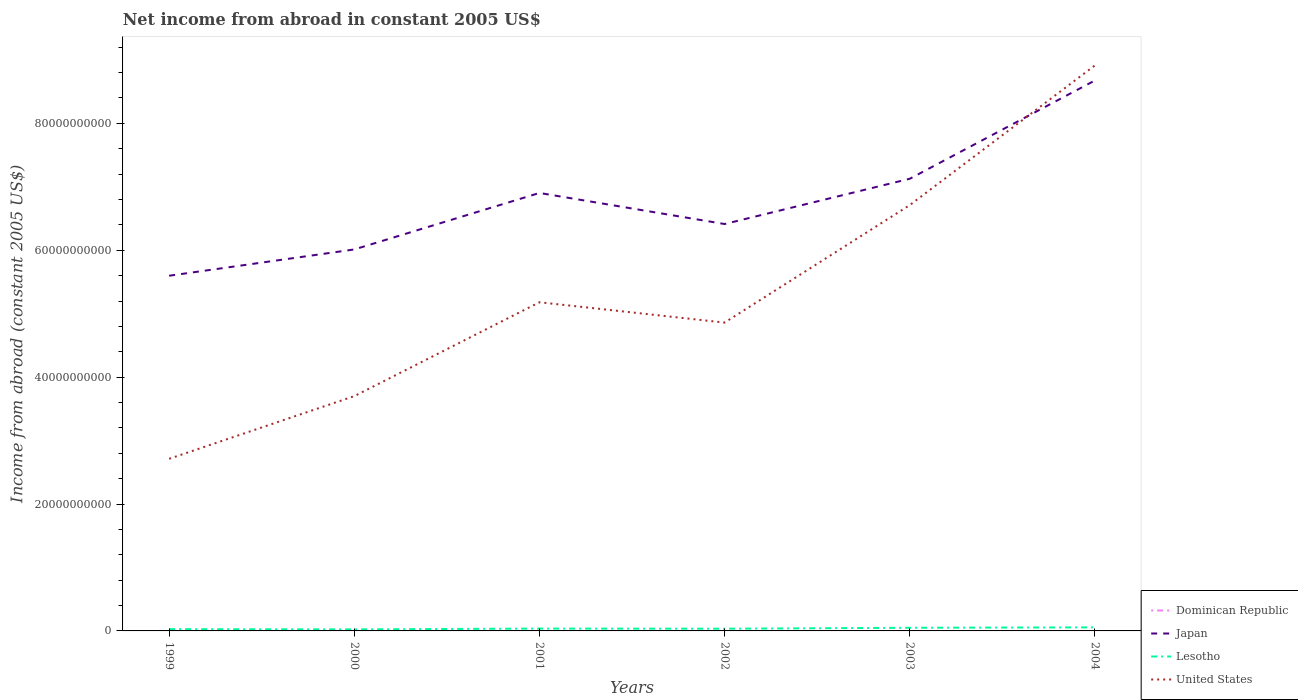Does the line corresponding to Lesotho intersect with the line corresponding to Japan?
Your answer should be very brief. No. Across all years, what is the maximum net income from abroad in Japan?
Give a very brief answer. 5.60e+1. What is the total net income from abroad in Japan in the graph?
Provide a short and direct response. -2.26e+1. What is the difference between the highest and the second highest net income from abroad in Japan?
Ensure brevity in your answer.  3.08e+1. Is the net income from abroad in Japan strictly greater than the net income from abroad in United States over the years?
Offer a terse response. No. How many years are there in the graph?
Your answer should be compact. 6. Are the values on the major ticks of Y-axis written in scientific E-notation?
Provide a succinct answer. No. Does the graph contain any zero values?
Your response must be concise. Yes. How many legend labels are there?
Offer a terse response. 4. What is the title of the graph?
Make the answer very short. Net income from abroad in constant 2005 US$. Does "Middle income" appear as one of the legend labels in the graph?
Make the answer very short. No. What is the label or title of the Y-axis?
Your response must be concise. Income from abroad (constant 2005 US$). What is the Income from abroad (constant 2005 US$) of Japan in 1999?
Give a very brief answer. 5.60e+1. What is the Income from abroad (constant 2005 US$) in Lesotho in 1999?
Offer a very short reply. 2.82e+08. What is the Income from abroad (constant 2005 US$) in United States in 1999?
Keep it short and to the point. 2.71e+1. What is the Income from abroad (constant 2005 US$) of Dominican Republic in 2000?
Your answer should be compact. 0. What is the Income from abroad (constant 2005 US$) of Japan in 2000?
Your answer should be very brief. 6.01e+1. What is the Income from abroad (constant 2005 US$) of Lesotho in 2000?
Your answer should be very brief. 2.43e+08. What is the Income from abroad (constant 2005 US$) of United States in 2000?
Make the answer very short. 3.70e+1. What is the Income from abroad (constant 2005 US$) of Japan in 2001?
Your answer should be very brief. 6.90e+1. What is the Income from abroad (constant 2005 US$) of Lesotho in 2001?
Ensure brevity in your answer.  3.69e+08. What is the Income from abroad (constant 2005 US$) in United States in 2001?
Ensure brevity in your answer.  5.18e+1. What is the Income from abroad (constant 2005 US$) in Japan in 2002?
Ensure brevity in your answer.  6.41e+1. What is the Income from abroad (constant 2005 US$) in Lesotho in 2002?
Offer a very short reply. 3.48e+08. What is the Income from abroad (constant 2005 US$) in United States in 2002?
Offer a terse response. 4.86e+1. What is the Income from abroad (constant 2005 US$) of Japan in 2003?
Offer a very short reply. 7.13e+1. What is the Income from abroad (constant 2005 US$) of Lesotho in 2003?
Offer a terse response. 4.97e+08. What is the Income from abroad (constant 2005 US$) of United States in 2003?
Provide a short and direct response. 6.71e+1. What is the Income from abroad (constant 2005 US$) in Japan in 2004?
Your response must be concise. 8.68e+1. What is the Income from abroad (constant 2005 US$) of Lesotho in 2004?
Your response must be concise. 5.62e+08. What is the Income from abroad (constant 2005 US$) of United States in 2004?
Give a very brief answer. 8.91e+1. Across all years, what is the maximum Income from abroad (constant 2005 US$) of Japan?
Offer a very short reply. 8.68e+1. Across all years, what is the maximum Income from abroad (constant 2005 US$) of Lesotho?
Provide a short and direct response. 5.62e+08. Across all years, what is the maximum Income from abroad (constant 2005 US$) of United States?
Provide a succinct answer. 8.91e+1. Across all years, what is the minimum Income from abroad (constant 2005 US$) of Japan?
Keep it short and to the point. 5.60e+1. Across all years, what is the minimum Income from abroad (constant 2005 US$) in Lesotho?
Keep it short and to the point. 2.43e+08. Across all years, what is the minimum Income from abroad (constant 2005 US$) in United States?
Provide a succinct answer. 2.71e+1. What is the total Income from abroad (constant 2005 US$) of Dominican Republic in the graph?
Keep it short and to the point. 0. What is the total Income from abroad (constant 2005 US$) in Japan in the graph?
Offer a terse response. 4.07e+11. What is the total Income from abroad (constant 2005 US$) of Lesotho in the graph?
Provide a succinct answer. 2.30e+09. What is the total Income from abroad (constant 2005 US$) in United States in the graph?
Keep it short and to the point. 3.21e+11. What is the difference between the Income from abroad (constant 2005 US$) in Japan in 1999 and that in 2000?
Your answer should be very brief. -4.14e+09. What is the difference between the Income from abroad (constant 2005 US$) of Lesotho in 1999 and that in 2000?
Ensure brevity in your answer.  3.91e+07. What is the difference between the Income from abroad (constant 2005 US$) of United States in 1999 and that in 2000?
Your answer should be compact. -9.88e+09. What is the difference between the Income from abroad (constant 2005 US$) in Japan in 1999 and that in 2001?
Your answer should be compact. -1.30e+1. What is the difference between the Income from abroad (constant 2005 US$) in Lesotho in 1999 and that in 2001?
Make the answer very short. -8.63e+07. What is the difference between the Income from abroad (constant 2005 US$) of United States in 1999 and that in 2001?
Keep it short and to the point. -2.47e+1. What is the difference between the Income from abroad (constant 2005 US$) of Japan in 1999 and that in 2002?
Make the answer very short. -8.15e+09. What is the difference between the Income from abroad (constant 2005 US$) in Lesotho in 1999 and that in 2002?
Your answer should be compact. -6.52e+07. What is the difference between the Income from abroad (constant 2005 US$) in United States in 1999 and that in 2002?
Your answer should be compact. -2.15e+1. What is the difference between the Income from abroad (constant 2005 US$) in Japan in 1999 and that in 2003?
Make the answer very short. -1.53e+1. What is the difference between the Income from abroad (constant 2005 US$) in Lesotho in 1999 and that in 2003?
Your answer should be very brief. -2.15e+08. What is the difference between the Income from abroad (constant 2005 US$) of United States in 1999 and that in 2003?
Keep it short and to the point. -4.00e+1. What is the difference between the Income from abroad (constant 2005 US$) in Japan in 1999 and that in 2004?
Offer a very short reply. -3.08e+1. What is the difference between the Income from abroad (constant 2005 US$) of Lesotho in 1999 and that in 2004?
Ensure brevity in your answer.  -2.79e+08. What is the difference between the Income from abroad (constant 2005 US$) in United States in 1999 and that in 2004?
Offer a very short reply. -6.20e+1. What is the difference between the Income from abroad (constant 2005 US$) in Japan in 2000 and that in 2001?
Provide a short and direct response. -8.90e+09. What is the difference between the Income from abroad (constant 2005 US$) in Lesotho in 2000 and that in 2001?
Your answer should be very brief. -1.25e+08. What is the difference between the Income from abroad (constant 2005 US$) of United States in 2000 and that in 2001?
Your answer should be very brief. -1.48e+1. What is the difference between the Income from abroad (constant 2005 US$) of Japan in 2000 and that in 2002?
Offer a terse response. -4.01e+09. What is the difference between the Income from abroad (constant 2005 US$) in Lesotho in 2000 and that in 2002?
Keep it short and to the point. -1.04e+08. What is the difference between the Income from abroad (constant 2005 US$) of United States in 2000 and that in 2002?
Ensure brevity in your answer.  -1.16e+1. What is the difference between the Income from abroad (constant 2005 US$) in Japan in 2000 and that in 2003?
Offer a terse response. -1.11e+1. What is the difference between the Income from abroad (constant 2005 US$) in Lesotho in 2000 and that in 2003?
Provide a succinct answer. -2.54e+08. What is the difference between the Income from abroad (constant 2005 US$) of United States in 2000 and that in 2003?
Keep it short and to the point. -3.01e+1. What is the difference between the Income from abroad (constant 2005 US$) of Japan in 2000 and that in 2004?
Provide a short and direct response. -2.66e+1. What is the difference between the Income from abroad (constant 2005 US$) in Lesotho in 2000 and that in 2004?
Provide a short and direct response. -3.18e+08. What is the difference between the Income from abroad (constant 2005 US$) of United States in 2000 and that in 2004?
Make the answer very short. -5.21e+1. What is the difference between the Income from abroad (constant 2005 US$) of Japan in 2001 and that in 2002?
Your answer should be very brief. 4.90e+09. What is the difference between the Income from abroad (constant 2005 US$) of Lesotho in 2001 and that in 2002?
Provide a succinct answer. 2.12e+07. What is the difference between the Income from abroad (constant 2005 US$) in United States in 2001 and that in 2002?
Your answer should be very brief. 3.20e+09. What is the difference between the Income from abroad (constant 2005 US$) of Japan in 2001 and that in 2003?
Ensure brevity in your answer.  -2.24e+09. What is the difference between the Income from abroad (constant 2005 US$) in Lesotho in 2001 and that in 2003?
Give a very brief answer. -1.28e+08. What is the difference between the Income from abroad (constant 2005 US$) in United States in 2001 and that in 2003?
Ensure brevity in your answer.  -1.53e+1. What is the difference between the Income from abroad (constant 2005 US$) in Japan in 2001 and that in 2004?
Give a very brief answer. -1.77e+1. What is the difference between the Income from abroad (constant 2005 US$) of Lesotho in 2001 and that in 2004?
Offer a very short reply. -1.93e+08. What is the difference between the Income from abroad (constant 2005 US$) in United States in 2001 and that in 2004?
Give a very brief answer. -3.73e+1. What is the difference between the Income from abroad (constant 2005 US$) in Japan in 2002 and that in 2003?
Your response must be concise. -7.13e+09. What is the difference between the Income from abroad (constant 2005 US$) of Lesotho in 2002 and that in 2003?
Make the answer very short. -1.50e+08. What is the difference between the Income from abroad (constant 2005 US$) in United States in 2002 and that in 2003?
Keep it short and to the point. -1.85e+1. What is the difference between the Income from abroad (constant 2005 US$) of Japan in 2002 and that in 2004?
Offer a very short reply. -2.26e+1. What is the difference between the Income from abroad (constant 2005 US$) of Lesotho in 2002 and that in 2004?
Offer a terse response. -2.14e+08. What is the difference between the Income from abroad (constant 2005 US$) in United States in 2002 and that in 2004?
Your answer should be very brief. -4.05e+1. What is the difference between the Income from abroad (constant 2005 US$) in Japan in 2003 and that in 2004?
Make the answer very short. -1.55e+1. What is the difference between the Income from abroad (constant 2005 US$) of Lesotho in 2003 and that in 2004?
Offer a very short reply. -6.46e+07. What is the difference between the Income from abroad (constant 2005 US$) in United States in 2003 and that in 2004?
Keep it short and to the point. -2.20e+1. What is the difference between the Income from abroad (constant 2005 US$) of Japan in 1999 and the Income from abroad (constant 2005 US$) of Lesotho in 2000?
Your response must be concise. 5.57e+1. What is the difference between the Income from abroad (constant 2005 US$) in Japan in 1999 and the Income from abroad (constant 2005 US$) in United States in 2000?
Provide a succinct answer. 1.90e+1. What is the difference between the Income from abroad (constant 2005 US$) of Lesotho in 1999 and the Income from abroad (constant 2005 US$) of United States in 2000?
Make the answer very short. -3.67e+1. What is the difference between the Income from abroad (constant 2005 US$) in Japan in 1999 and the Income from abroad (constant 2005 US$) in Lesotho in 2001?
Offer a terse response. 5.56e+1. What is the difference between the Income from abroad (constant 2005 US$) of Japan in 1999 and the Income from abroad (constant 2005 US$) of United States in 2001?
Give a very brief answer. 4.18e+09. What is the difference between the Income from abroad (constant 2005 US$) in Lesotho in 1999 and the Income from abroad (constant 2005 US$) in United States in 2001?
Keep it short and to the point. -5.15e+1. What is the difference between the Income from abroad (constant 2005 US$) in Japan in 1999 and the Income from abroad (constant 2005 US$) in Lesotho in 2002?
Offer a terse response. 5.56e+1. What is the difference between the Income from abroad (constant 2005 US$) in Japan in 1999 and the Income from abroad (constant 2005 US$) in United States in 2002?
Give a very brief answer. 7.38e+09. What is the difference between the Income from abroad (constant 2005 US$) in Lesotho in 1999 and the Income from abroad (constant 2005 US$) in United States in 2002?
Give a very brief answer. -4.83e+1. What is the difference between the Income from abroad (constant 2005 US$) of Japan in 1999 and the Income from abroad (constant 2005 US$) of Lesotho in 2003?
Ensure brevity in your answer.  5.55e+1. What is the difference between the Income from abroad (constant 2005 US$) of Japan in 1999 and the Income from abroad (constant 2005 US$) of United States in 2003?
Your answer should be compact. -1.11e+1. What is the difference between the Income from abroad (constant 2005 US$) of Lesotho in 1999 and the Income from abroad (constant 2005 US$) of United States in 2003?
Make the answer very short. -6.68e+1. What is the difference between the Income from abroad (constant 2005 US$) of Japan in 1999 and the Income from abroad (constant 2005 US$) of Lesotho in 2004?
Offer a terse response. 5.54e+1. What is the difference between the Income from abroad (constant 2005 US$) of Japan in 1999 and the Income from abroad (constant 2005 US$) of United States in 2004?
Your answer should be compact. -3.31e+1. What is the difference between the Income from abroad (constant 2005 US$) of Lesotho in 1999 and the Income from abroad (constant 2005 US$) of United States in 2004?
Your answer should be very brief. -8.88e+1. What is the difference between the Income from abroad (constant 2005 US$) of Japan in 2000 and the Income from abroad (constant 2005 US$) of Lesotho in 2001?
Ensure brevity in your answer.  5.98e+1. What is the difference between the Income from abroad (constant 2005 US$) in Japan in 2000 and the Income from abroad (constant 2005 US$) in United States in 2001?
Give a very brief answer. 8.32e+09. What is the difference between the Income from abroad (constant 2005 US$) of Lesotho in 2000 and the Income from abroad (constant 2005 US$) of United States in 2001?
Your answer should be very brief. -5.16e+1. What is the difference between the Income from abroad (constant 2005 US$) of Japan in 2000 and the Income from abroad (constant 2005 US$) of Lesotho in 2002?
Offer a terse response. 5.98e+1. What is the difference between the Income from abroad (constant 2005 US$) of Japan in 2000 and the Income from abroad (constant 2005 US$) of United States in 2002?
Make the answer very short. 1.15e+1. What is the difference between the Income from abroad (constant 2005 US$) of Lesotho in 2000 and the Income from abroad (constant 2005 US$) of United States in 2002?
Offer a very short reply. -4.84e+1. What is the difference between the Income from abroad (constant 2005 US$) in Japan in 2000 and the Income from abroad (constant 2005 US$) in Lesotho in 2003?
Offer a terse response. 5.96e+1. What is the difference between the Income from abroad (constant 2005 US$) in Japan in 2000 and the Income from abroad (constant 2005 US$) in United States in 2003?
Your answer should be compact. -6.99e+09. What is the difference between the Income from abroad (constant 2005 US$) of Lesotho in 2000 and the Income from abroad (constant 2005 US$) of United States in 2003?
Provide a short and direct response. -6.69e+1. What is the difference between the Income from abroad (constant 2005 US$) of Japan in 2000 and the Income from abroad (constant 2005 US$) of Lesotho in 2004?
Offer a terse response. 5.96e+1. What is the difference between the Income from abroad (constant 2005 US$) in Japan in 2000 and the Income from abroad (constant 2005 US$) in United States in 2004?
Provide a short and direct response. -2.90e+1. What is the difference between the Income from abroad (constant 2005 US$) in Lesotho in 2000 and the Income from abroad (constant 2005 US$) in United States in 2004?
Your response must be concise. -8.89e+1. What is the difference between the Income from abroad (constant 2005 US$) in Japan in 2001 and the Income from abroad (constant 2005 US$) in Lesotho in 2002?
Provide a succinct answer. 6.87e+1. What is the difference between the Income from abroad (constant 2005 US$) in Japan in 2001 and the Income from abroad (constant 2005 US$) in United States in 2002?
Give a very brief answer. 2.04e+1. What is the difference between the Income from abroad (constant 2005 US$) of Lesotho in 2001 and the Income from abroad (constant 2005 US$) of United States in 2002?
Keep it short and to the point. -4.82e+1. What is the difference between the Income from abroad (constant 2005 US$) in Japan in 2001 and the Income from abroad (constant 2005 US$) in Lesotho in 2003?
Give a very brief answer. 6.85e+1. What is the difference between the Income from abroad (constant 2005 US$) in Japan in 2001 and the Income from abroad (constant 2005 US$) in United States in 2003?
Keep it short and to the point. 1.92e+09. What is the difference between the Income from abroad (constant 2005 US$) of Lesotho in 2001 and the Income from abroad (constant 2005 US$) of United States in 2003?
Your answer should be compact. -6.67e+1. What is the difference between the Income from abroad (constant 2005 US$) of Japan in 2001 and the Income from abroad (constant 2005 US$) of Lesotho in 2004?
Provide a succinct answer. 6.85e+1. What is the difference between the Income from abroad (constant 2005 US$) in Japan in 2001 and the Income from abroad (constant 2005 US$) in United States in 2004?
Provide a succinct answer. -2.01e+1. What is the difference between the Income from abroad (constant 2005 US$) in Lesotho in 2001 and the Income from abroad (constant 2005 US$) in United States in 2004?
Ensure brevity in your answer.  -8.88e+1. What is the difference between the Income from abroad (constant 2005 US$) of Japan in 2002 and the Income from abroad (constant 2005 US$) of Lesotho in 2003?
Your answer should be compact. 6.36e+1. What is the difference between the Income from abroad (constant 2005 US$) in Japan in 2002 and the Income from abroad (constant 2005 US$) in United States in 2003?
Ensure brevity in your answer.  -2.98e+09. What is the difference between the Income from abroad (constant 2005 US$) in Lesotho in 2002 and the Income from abroad (constant 2005 US$) in United States in 2003?
Ensure brevity in your answer.  -6.68e+1. What is the difference between the Income from abroad (constant 2005 US$) of Japan in 2002 and the Income from abroad (constant 2005 US$) of Lesotho in 2004?
Ensure brevity in your answer.  6.36e+1. What is the difference between the Income from abroad (constant 2005 US$) of Japan in 2002 and the Income from abroad (constant 2005 US$) of United States in 2004?
Make the answer very short. -2.50e+1. What is the difference between the Income from abroad (constant 2005 US$) in Lesotho in 2002 and the Income from abroad (constant 2005 US$) in United States in 2004?
Your response must be concise. -8.88e+1. What is the difference between the Income from abroad (constant 2005 US$) in Japan in 2003 and the Income from abroad (constant 2005 US$) in Lesotho in 2004?
Give a very brief answer. 7.07e+1. What is the difference between the Income from abroad (constant 2005 US$) of Japan in 2003 and the Income from abroad (constant 2005 US$) of United States in 2004?
Make the answer very short. -1.79e+1. What is the difference between the Income from abroad (constant 2005 US$) in Lesotho in 2003 and the Income from abroad (constant 2005 US$) in United States in 2004?
Offer a very short reply. -8.86e+1. What is the average Income from abroad (constant 2005 US$) in Dominican Republic per year?
Offer a very short reply. 0. What is the average Income from abroad (constant 2005 US$) in Japan per year?
Offer a very short reply. 6.79e+1. What is the average Income from abroad (constant 2005 US$) of Lesotho per year?
Provide a succinct answer. 3.83e+08. What is the average Income from abroad (constant 2005 US$) in United States per year?
Give a very brief answer. 5.35e+1. In the year 1999, what is the difference between the Income from abroad (constant 2005 US$) in Japan and Income from abroad (constant 2005 US$) in Lesotho?
Provide a short and direct response. 5.57e+1. In the year 1999, what is the difference between the Income from abroad (constant 2005 US$) of Japan and Income from abroad (constant 2005 US$) of United States?
Provide a short and direct response. 2.89e+1. In the year 1999, what is the difference between the Income from abroad (constant 2005 US$) in Lesotho and Income from abroad (constant 2005 US$) in United States?
Offer a very short reply. -2.68e+1. In the year 2000, what is the difference between the Income from abroad (constant 2005 US$) of Japan and Income from abroad (constant 2005 US$) of Lesotho?
Provide a short and direct response. 5.99e+1. In the year 2000, what is the difference between the Income from abroad (constant 2005 US$) in Japan and Income from abroad (constant 2005 US$) in United States?
Provide a short and direct response. 2.31e+1. In the year 2000, what is the difference between the Income from abroad (constant 2005 US$) of Lesotho and Income from abroad (constant 2005 US$) of United States?
Provide a short and direct response. -3.68e+1. In the year 2001, what is the difference between the Income from abroad (constant 2005 US$) of Japan and Income from abroad (constant 2005 US$) of Lesotho?
Provide a short and direct response. 6.87e+1. In the year 2001, what is the difference between the Income from abroad (constant 2005 US$) in Japan and Income from abroad (constant 2005 US$) in United States?
Ensure brevity in your answer.  1.72e+1. In the year 2001, what is the difference between the Income from abroad (constant 2005 US$) in Lesotho and Income from abroad (constant 2005 US$) in United States?
Your answer should be compact. -5.14e+1. In the year 2002, what is the difference between the Income from abroad (constant 2005 US$) of Japan and Income from abroad (constant 2005 US$) of Lesotho?
Ensure brevity in your answer.  6.38e+1. In the year 2002, what is the difference between the Income from abroad (constant 2005 US$) of Japan and Income from abroad (constant 2005 US$) of United States?
Offer a very short reply. 1.55e+1. In the year 2002, what is the difference between the Income from abroad (constant 2005 US$) of Lesotho and Income from abroad (constant 2005 US$) of United States?
Make the answer very short. -4.83e+1. In the year 2003, what is the difference between the Income from abroad (constant 2005 US$) in Japan and Income from abroad (constant 2005 US$) in Lesotho?
Keep it short and to the point. 7.08e+1. In the year 2003, what is the difference between the Income from abroad (constant 2005 US$) in Japan and Income from abroad (constant 2005 US$) in United States?
Make the answer very short. 4.15e+09. In the year 2003, what is the difference between the Income from abroad (constant 2005 US$) in Lesotho and Income from abroad (constant 2005 US$) in United States?
Give a very brief answer. -6.66e+1. In the year 2004, what is the difference between the Income from abroad (constant 2005 US$) of Japan and Income from abroad (constant 2005 US$) of Lesotho?
Your answer should be compact. 8.62e+1. In the year 2004, what is the difference between the Income from abroad (constant 2005 US$) in Japan and Income from abroad (constant 2005 US$) in United States?
Ensure brevity in your answer.  -2.38e+09. In the year 2004, what is the difference between the Income from abroad (constant 2005 US$) of Lesotho and Income from abroad (constant 2005 US$) of United States?
Offer a very short reply. -8.86e+1. What is the ratio of the Income from abroad (constant 2005 US$) in Japan in 1999 to that in 2000?
Keep it short and to the point. 0.93. What is the ratio of the Income from abroad (constant 2005 US$) in Lesotho in 1999 to that in 2000?
Offer a very short reply. 1.16. What is the ratio of the Income from abroad (constant 2005 US$) of United States in 1999 to that in 2000?
Make the answer very short. 0.73. What is the ratio of the Income from abroad (constant 2005 US$) of Japan in 1999 to that in 2001?
Offer a terse response. 0.81. What is the ratio of the Income from abroad (constant 2005 US$) in Lesotho in 1999 to that in 2001?
Make the answer very short. 0.77. What is the ratio of the Income from abroad (constant 2005 US$) in United States in 1999 to that in 2001?
Offer a very short reply. 0.52. What is the ratio of the Income from abroad (constant 2005 US$) in Japan in 1999 to that in 2002?
Give a very brief answer. 0.87. What is the ratio of the Income from abroad (constant 2005 US$) in Lesotho in 1999 to that in 2002?
Provide a succinct answer. 0.81. What is the ratio of the Income from abroad (constant 2005 US$) in United States in 1999 to that in 2002?
Make the answer very short. 0.56. What is the ratio of the Income from abroad (constant 2005 US$) of Japan in 1999 to that in 2003?
Make the answer very short. 0.79. What is the ratio of the Income from abroad (constant 2005 US$) of Lesotho in 1999 to that in 2003?
Your response must be concise. 0.57. What is the ratio of the Income from abroad (constant 2005 US$) in United States in 1999 to that in 2003?
Your response must be concise. 0.4. What is the ratio of the Income from abroad (constant 2005 US$) in Japan in 1999 to that in 2004?
Offer a very short reply. 0.65. What is the ratio of the Income from abroad (constant 2005 US$) in Lesotho in 1999 to that in 2004?
Provide a succinct answer. 0.5. What is the ratio of the Income from abroad (constant 2005 US$) of United States in 1999 to that in 2004?
Give a very brief answer. 0.3. What is the ratio of the Income from abroad (constant 2005 US$) of Japan in 2000 to that in 2001?
Ensure brevity in your answer.  0.87. What is the ratio of the Income from abroad (constant 2005 US$) in Lesotho in 2000 to that in 2001?
Give a very brief answer. 0.66. What is the ratio of the Income from abroad (constant 2005 US$) of United States in 2000 to that in 2001?
Keep it short and to the point. 0.71. What is the ratio of the Income from abroad (constant 2005 US$) of Japan in 2000 to that in 2002?
Give a very brief answer. 0.94. What is the ratio of the Income from abroad (constant 2005 US$) of Lesotho in 2000 to that in 2002?
Ensure brevity in your answer.  0.7. What is the ratio of the Income from abroad (constant 2005 US$) in United States in 2000 to that in 2002?
Provide a succinct answer. 0.76. What is the ratio of the Income from abroad (constant 2005 US$) of Japan in 2000 to that in 2003?
Ensure brevity in your answer.  0.84. What is the ratio of the Income from abroad (constant 2005 US$) of Lesotho in 2000 to that in 2003?
Provide a succinct answer. 0.49. What is the ratio of the Income from abroad (constant 2005 US$) of United States in 2000 to that in 2003?
Offer a terse response. 0.55. What is the ratio of the Income from abroad (constant 2005 US$) in Japan in 2000 to that in 2004?
Your response must be concise. 0.69. What is the ratio of the Income from abroad (constant 2005 US$) of Lesotho in 2000 to that in 2004?
Provide a succinct answer. 0.43. What is the ratio of the Income from abroad (constant 2005 US$) of United States in 2000 to that in 2004?
Your answer should be very brief. 0.42. What is the ratio of the Income from abroad (constant 2005 US$) in Japan in 2001 to that in 2002?
Offer a very short reply. 1.08. What is the ratio of the Income from abroad (constant 2005 US$) in Lesotho in 2001 to that in 2002?
Offer a very short reply. 1.06. What is the ratio of the Income from abroad (constant 2005 US$) in United States in 2001 to that in 2002?
Make the answer very short. 1.07. What is the ratio of the Income from abroad (constant 2005 US$) in Japan in 2001 to that in 2003?
Your answer should be compact. 0.97. What is the ratio of the Income from abroad (constant 2005 US$) of Lesotho in 2001 to that in 2003?
Offer a very short reply. 0.74. What is the ratio of the Income from abroad (constant 2005 US$) of United States in 2001 to that in 2003?
Your answer should be compact. 0.77. What is the ratio of the Income from abroad (constant 2005 US$) of Japan in 2001 to that in 2004?
Your answer should be compact. 0.8. What is the ratio of the Income from abroad (constant 2005 US$) in Lesotho in 2001 to that in 2004?
Provide a succinct answer. 0.66. What is the ratio of the Income from abroad (constant 2005 US$) of United States in 2001 to that in 2004?
Your answer should be very brief. 0.58. What is the ratio of the Income from abroad (constant 2005 US$) in Japan in 2002 to that in 2003?
Give a very brief answer. 0.9. What is the ratio of the Income from abroad (constant 2005 US$) in Lesotho in 2002 to that in 2003?
Offer a very short reply. 0.7. What is the ratio of the Income from abroad (constant 2005 US$) of United States in 2002 to that in 2003?
Ensure brevity in your answer.  0.72. What is the ratio of the Income from abroad (constant 2005 US$) in Japan in 2002 to that in 2004?
Your response must be concise. 0.74. What is the ratio of the Income from abroad (constant 2005 US$) in Lesotho in 2002 to that in 2004?
Keep it short and to the point. 0.62. What is the ratio of the Income from abroad (constant 2005 US$) of United States in 2002 to that in 2004?
Give a very brief answer. 0.55. What is the ratio of the Income from abroad (constant 2005 US$) in Japan in 2003 to that in 2004?
Keep it short and to the point. 0.82. What is the ratio of the Income from abroad (constant 2005 US$) in Lesotho in 2003 to that in 2004?
Make the answer very short. 0.89. What is the ratio of the Income from abroad (constant 2005 US$) in United States in 2003 to that in 2004?
Your response must be concise. 0.75. What is the difference between the highest and the second highest Income from abroad (constant 2005 US$) of Japan?
Offer a terse response. 1.55e+1. What is the difference between the highest and the second highest Income from abroad (constant 2005 US$) in Lesotho?
Provide a succinct answer. 6.46e+07. What is the difference between the highest and the second highest Income from abroad (constant 2005 US$) in United States?
Give a very brief answer. 2.20e+1. What is the difference between the highest and the lowest Income from abroad (constant 2005 US$) in Japan?
Keep it short and to the point. 3.08e+1. What is the difference between the highest and the lowest Income from abroad (constant 2005 US$) in Lesotho?
Your answer should be compact. 3.18e+08. What is the difference between the highest and the lowest Income from abroad (constant 2005 US$) in United States?
Your response must be concise. 6.20e+1. 